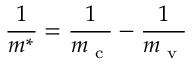<formula> <loc_0><loc_0><loc_500><loc_500>\frac { 1 } { m ^ { * } } = \frac { 1 } { m _ { c } } - \frac { 1 } { m _ { v } }</formula> 